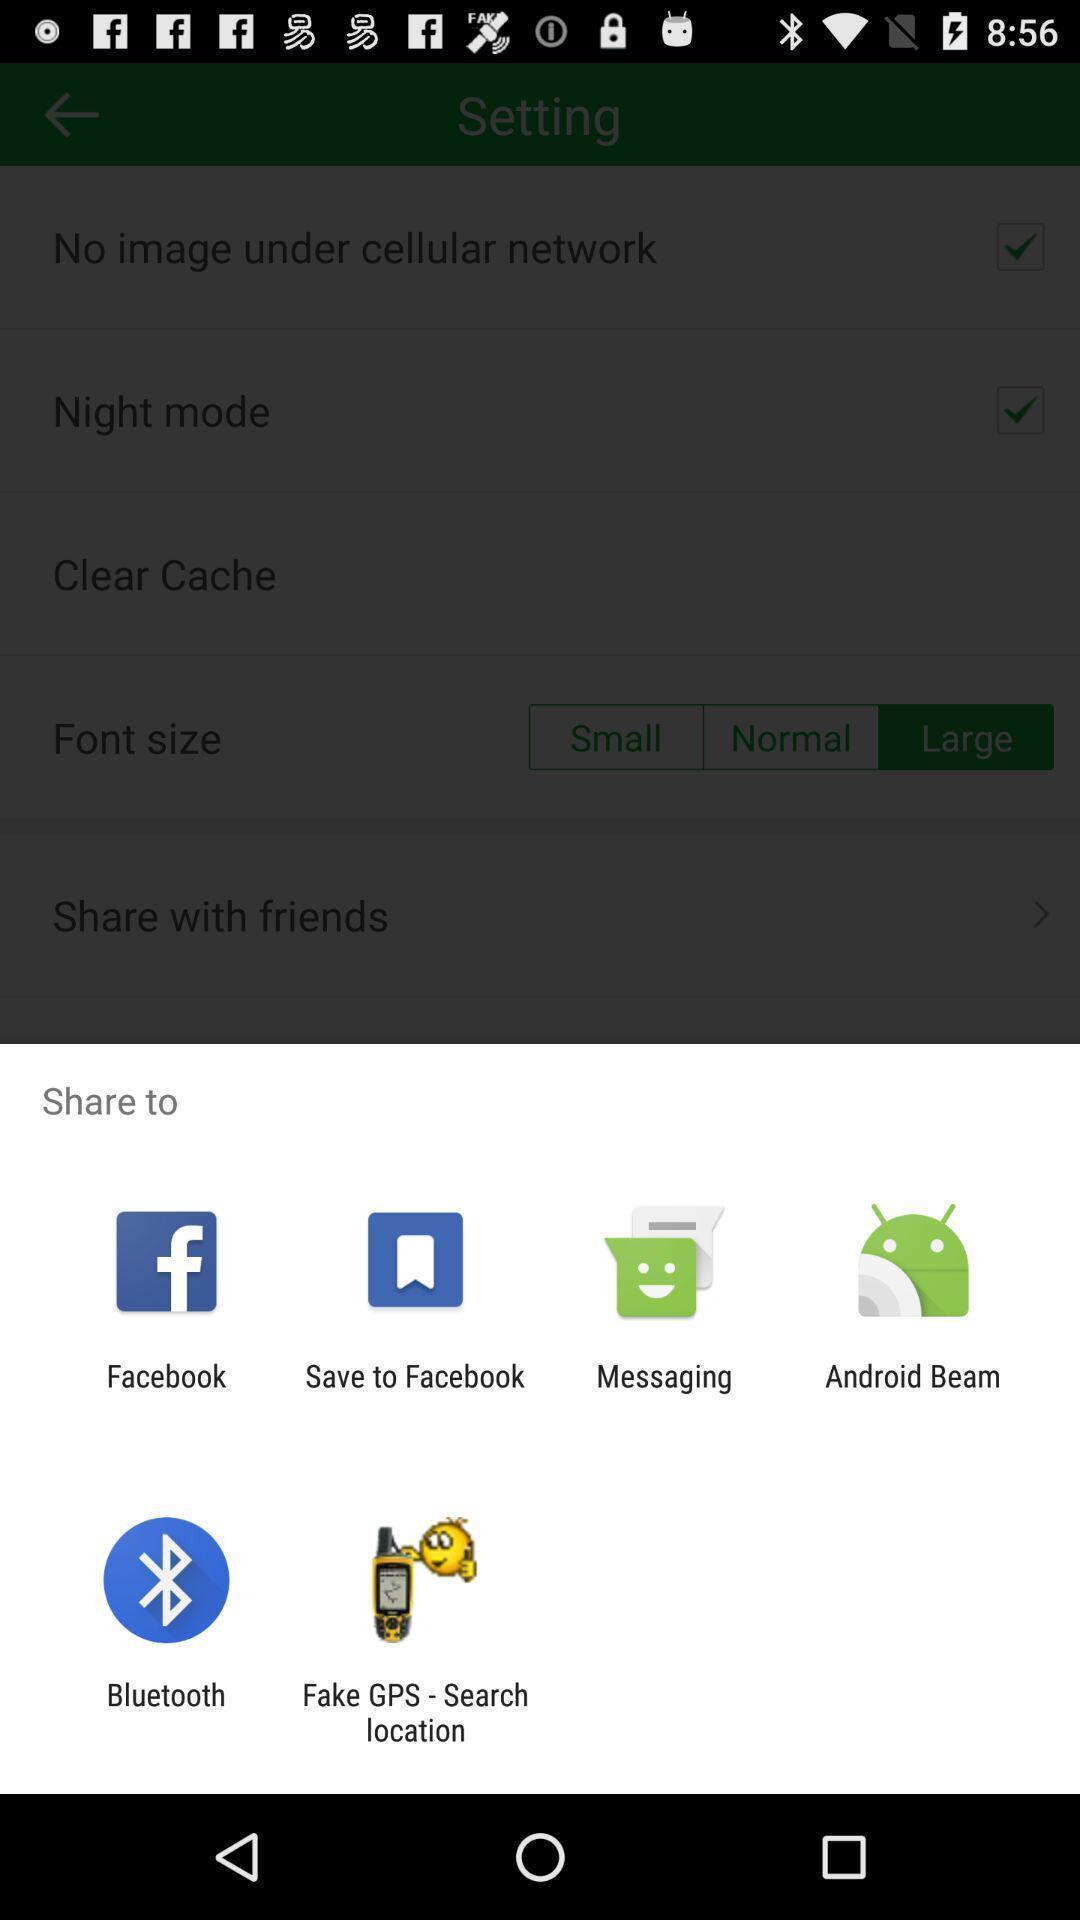Describe this image in words. Pop-up displaying list of apps to select. 